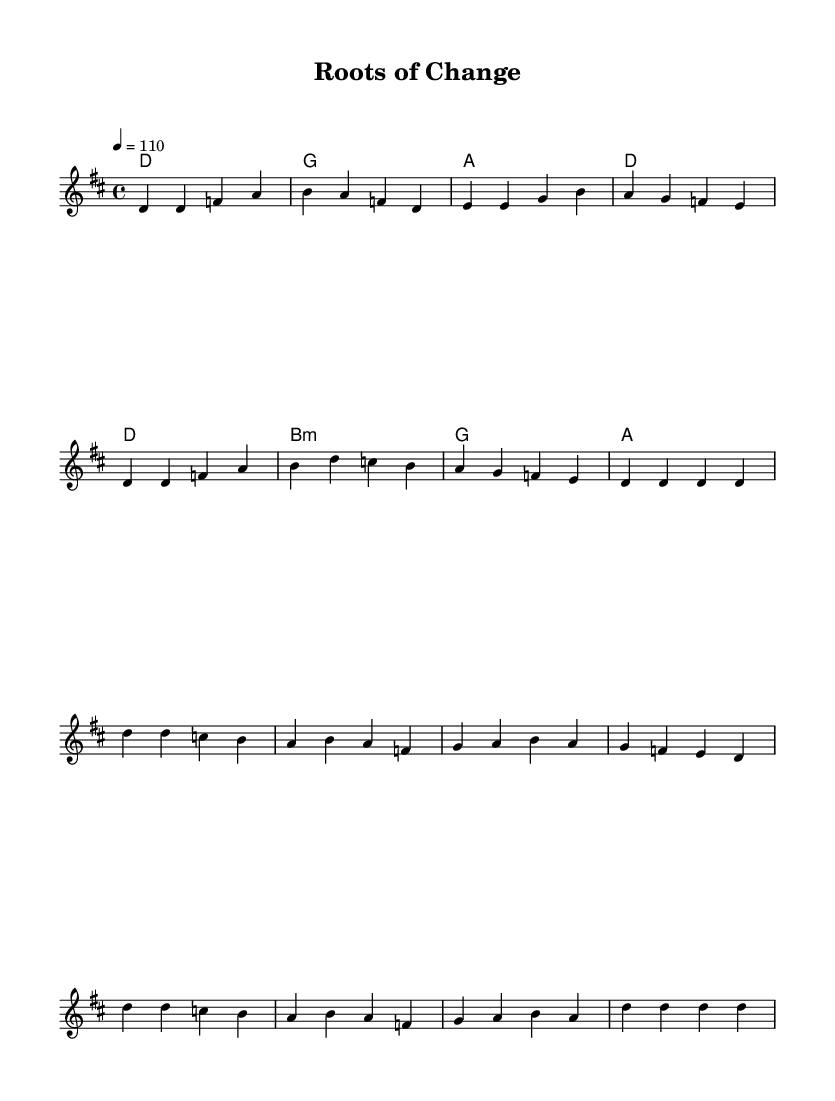What is the key signature of this music? The key signature is indicated at the beginning of the staff. In this piece, it shows two sharps, which corresponds to the D major scale.
Answer: D major What is the time signature of this music? The time signature is located at the beginning of the staff. It shows "4/4", indicating there are four beats in each measure and a quarter note receives one beat.
Answer: 4/4 What is the tempo marking for this piece? The tempo marking, shown at the beginning of the score, indicates how fast the music should be played. Here, it specifies "4 = 110", meaning there are 110 beats per minute.
Answer: 110 How many measures are in the verse? By counting the measures from the notation provided in the verse section, we see there are eight measures.
Answer: 8 What is the root chord of the first measure? The first measure's chord symbol (above the staff) indicates the harmony that is played. It displays "d", which signifies the D major chord.
Answer: D What lyrical theme is expressed in the chorus? Looking at the lyrics, especially the chorus lines provided, the theme revolves around sustainable dreams and rising together, which emphasizes community and collaboration.
Answer: Sustainable dreams What is the chord progression used in the chorus? By analyzing the chord symbols underneath the melody in the chorus section, we see the sequence: D, B minor, G, A. This shows how the harmony supports the melody.
Answer: D, B minor, G, A 